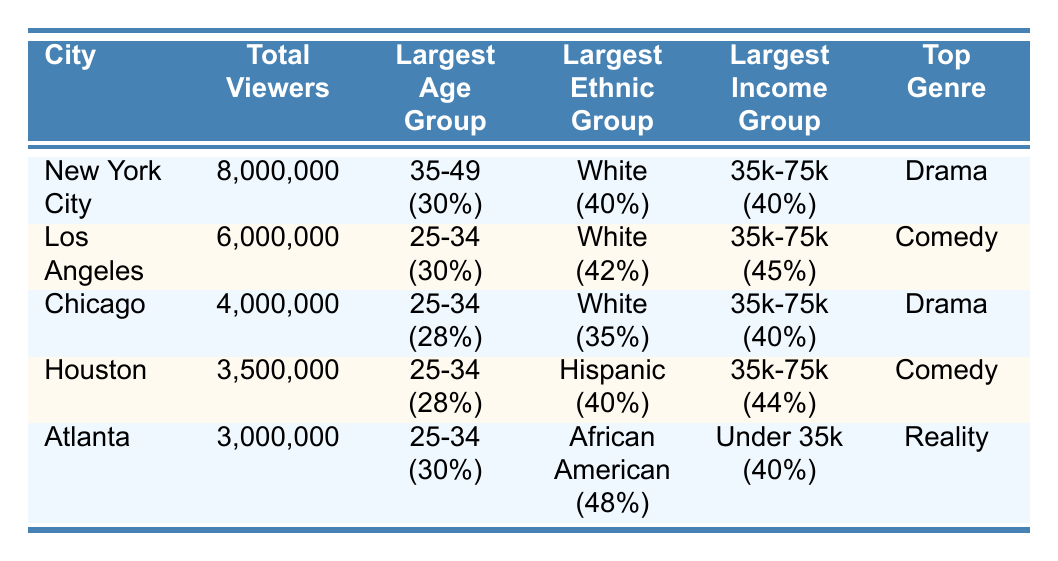What city has the highest total number of viewers? The total viewers for each city are listed: New York City has 8,000,000, Los Angeles has 6,000,000, Chicago has 4,000,000, Houston has 3,500,000, and Atlanta has 3,000,000. By comparing these numbers, New York City has the highest total number of viewers.
Answer: New York City What is the largest age group in Los Angeles? In the table, for Los Angeles, the age groups and their percentages are listed. The largest age group is 25-34, which has 30%.
Answer: 25-34 Which city has the largest percentage of African American viewers? The table shows the ethnic composition for each city. Atlanta has 48% African American viewers, which is higher than the percentages for other cities: New York City with 22%, Los Angeles with 15%, Chicago with 33%, and Houston with 24%. Therefore, Atlanta has the largest percentage of African American viewers.
Answer: Atlanta Is the largest income group in Chicago 35k-75k? For Chicago, the largest income group is listed as 35k-75k, which has 40%. Therefore, the statement is true.
Answer: Yes What is the average percentage of Hispanic viewers across all five cities? To find the average percentage of Hispanic viewers, we sum up all the percentages from each city: New York City (30%) + Los Angeles (30%) + Chicago (25%) + Houston (40%) + Atlanta (15%) = 140%. Then, we divide by the number of cities (5) to get the average: 140% / 5 = 28%.
Answer: 28% Which city has the top genre of "Drama"? The top genres for each city are stated in the table. New York City and Chicago both list "Drama" as their top genre. Thus, both cities have "Drama" as the top genre.
Answer: New York City and Chicago What is the income percentage for households earning under 35k in Houston? In Houston, the table indicates that the percentage of households earning under 35k is 32%. Thus, the answer is straightforward and can be found directly in the table.
Answer: 32% Which city has the lowest number of total viewers? Looking at the total viewers for each city, Atlanta has the lowest total viewers at 3,000,000 compared to the others: New York City (8,000,000), Los Angeles (6,000,000), Chicago (4,000,000), and Houston (3,500,000). Therefore, Atlanta has the lowest number of total viewers.
Answer: Atlanta 